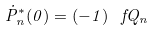<formula> <loc_0><loc_0><loc_500><loc_500>\dot { P } _ { n } ^ { * } ( 0 ) = ( - 1 ) ^ { \ } f Q _ { n }</formula> 